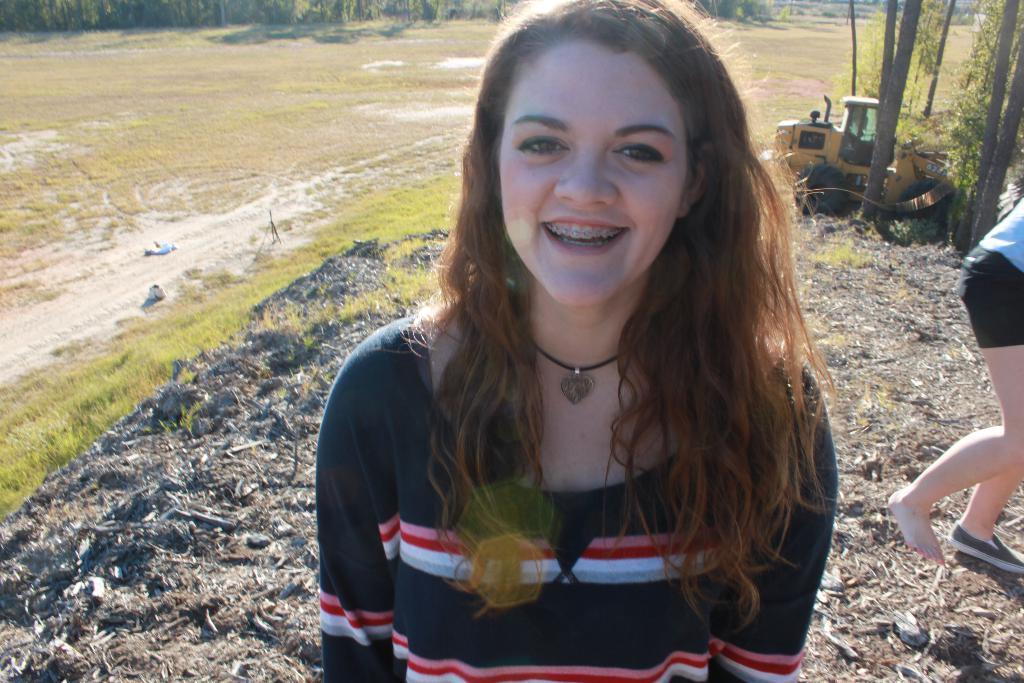Could you give a brief overview of what you see in this image? A beautiful girl is smiling, she wore a t-shirt. On the left side there is the grass, on the right side there is a vehicle in yellow color. 